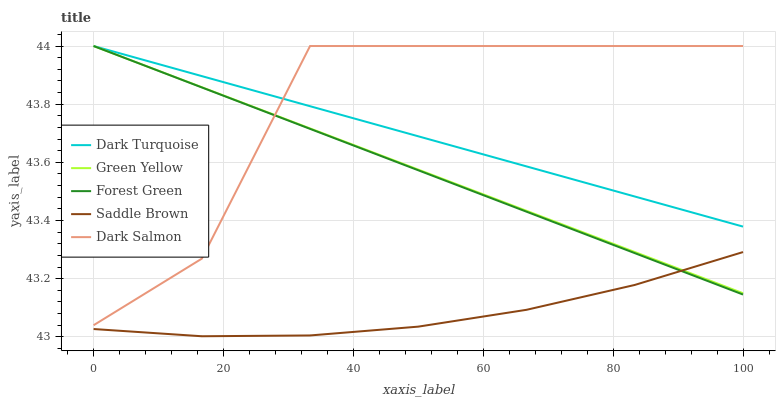Does Saddle Brown have the minimum area under the curve?
Answer yes or no. Yes. Does Dark Salmon have the maximum area under the curve?
Answer yes or no. Yes. Does Forest Green have the minimum area under the curve?
Answer yes or no. No. Does Forest Green have the maximum area under the curve?
Answer yes or no. No. Is Dark Turquoise the smoothest?
Answer yes or no. Yes. Is Dark Salmon the roughest?
Answer yes or no. Yes. Is Forest Green the smoothest?
Answer yes or no. No. Is Forest Green the roughest?
Answer yes or no. No. Does Saddle Brown have the lowest value?
Answer yes or no. Yes. Does Forest Green have the lowest value?
Answer yes or no. No. Does Dark Salmon have the highest value?
Answer yes or no. Yes. Does Saddle Brown have the highest value?
Answer yes or no. No. Is Saddle Brown less than Dark Turquoise?
Answer yes or no. Yes. Is Dark Turquoise greater than Saddle Brown?
Answer yes or no. Yes. Does Green Yellow intersect Dark Salmon?
Answer yes or no. Yes. Is Green Yellow less than Dark Salmon?
Answer yes or no. No. Is Green Yellow greater than Dark Salmon?
Answer yes or no. No. Does Saddle Brown intersect Dark Turquoise?
Answer yes or no. No. 